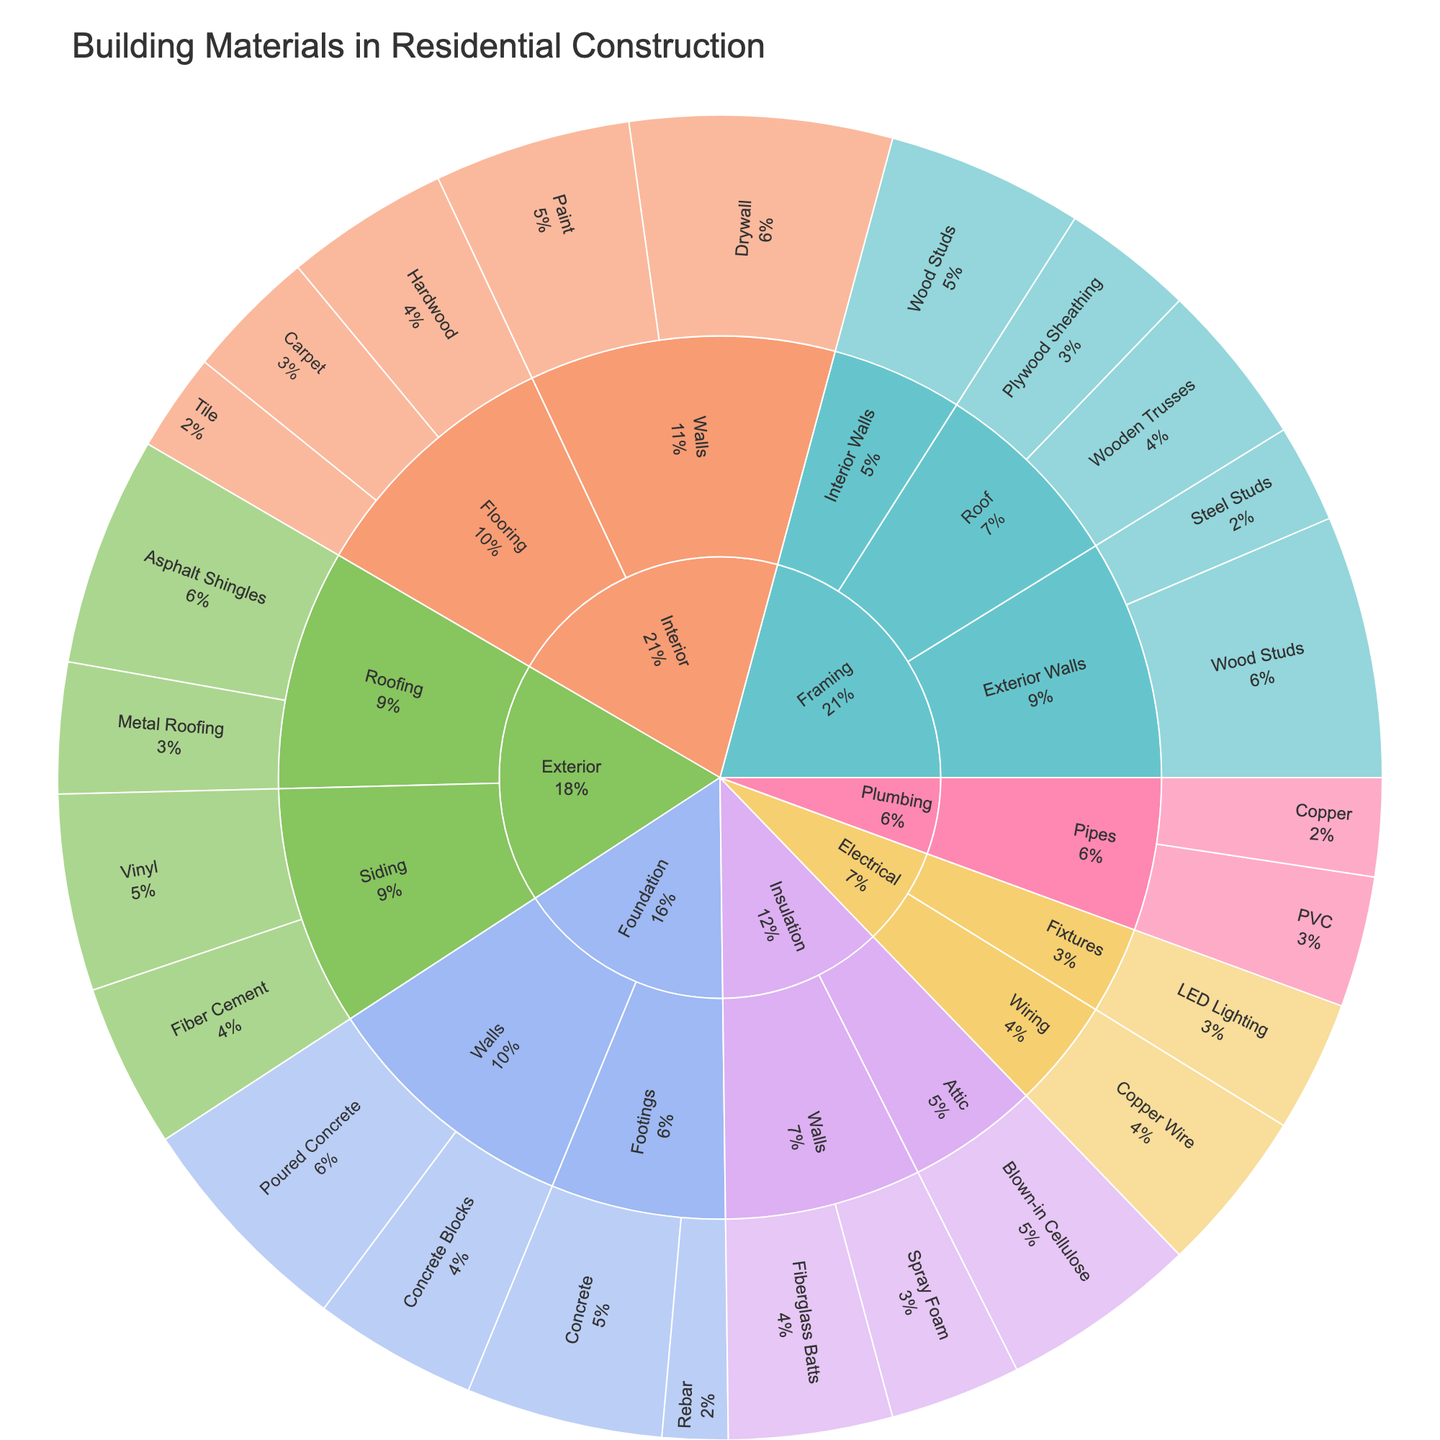What's the predominant material used in the framing of interior walls? Look at the 'Framing' category and then the 'Interior Walls' subcategory. The material with the largest section will be the predominant one.
Answer: Wood Studs Which material has the highest value in the 'Exterior' category? Navigate to the 'Exterior' category and compare the values of materials within it. Find the one with the highest value.
Answer: Asphalt Shingles What's the cumulative value of all materials used in the 'Foundation' category? Sum the values of materials within the 'Foundation' category: 30 (Concrete) + 10 (Rebar) + 25 (Concrete Blocks) + 35 (Poured Concrete).
Answer: 100 What percentage of the total does the 'Insulation' category represent? To get this, first sum the values of all materials in the sunburst plot. Then, sum the values in the 'Insulation' category and divide it by the total, multiplying by 100 for percentage. Total = 560, Insulation = 75. (75/560)*100 yields 13.4%.
Answer: 13.4% How does the value of 'PVC Pipes' used in plumbing compare to 'Copper Pipes'? Compare the values directly from the sunburst plot within the 'Plumbing' category. PVC is 20 and Copper is 15. Therefore, PVC is higher.
Answer: PVC is higher Which category has the least number of subcategories? Count the number of subcategories under each category and identify the one with the least. 'Plumbing' and 'Electrical' both have the least with 2 subcategories each.
Answer: Plumbing and Electrical What's the total value of materials used in 'Interior Walls'? Sum the values of all materials in the 'Interior Walls' subcategory: Drywall (40) + Paint (30).
Answer: 70 Can you identify the material with the smallest value and which subcategory it belongs to? Look for the smallest segment in the sunburst plot and identify its value and subcategory from the hover data. Rebar in 'Footings' has the smallest value of 10.
Answer: Rebar in Footings How does the combined value of wooden materials in the 'Framing' category compare to that of non-wooden materials? Sum the values of wooden materials (Wood Studs, Wooden Trusses, Plywood Sheathing) and non-wooden materials (Steel Studs). Wooden: 40 + 30 + 25 + 20 = 115, Non-Wooden: 15.
Answer: Wooden materials are higher What subcategory in 'Exterior' has the closest value to 'Fiber Cement Siding'? Compare the values within the 'Exterior' category. Fiber Cement Siding has a value of 25. Metal Roofing in 'Roofing' also has a value of 20, making it the closest.
Answer: Metal Roofing in Roofing has the closest value 